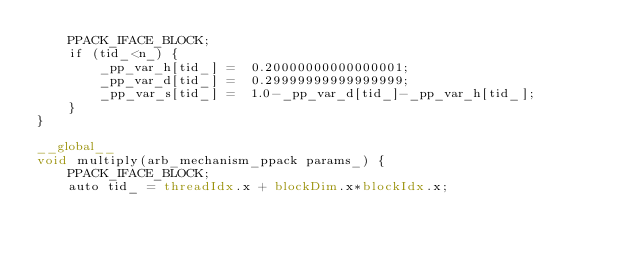Convert code to text. <code><loc_0><loc_0><loc_500><loc_500><_Cuda_>    PPACK_IFACE_BLOCK;
    if (tid_<n_) {
        _pp_var_h[tid_] =  0.20000000000000001;
        _pp_var_d[tid_] =  0.29999999999999999;
        _pp_var_s[tid_] =  1.0-_pp_var_d[tid_]-_pp_var_h[tid_];
    }
}

__global__
void multiply(arb_mechanism_ppack params_) {
    PPACK_IFACE_BLOCK;
    auto tid_ = threadIdx.x + blockDim.x*blockIdx.x;</code> 